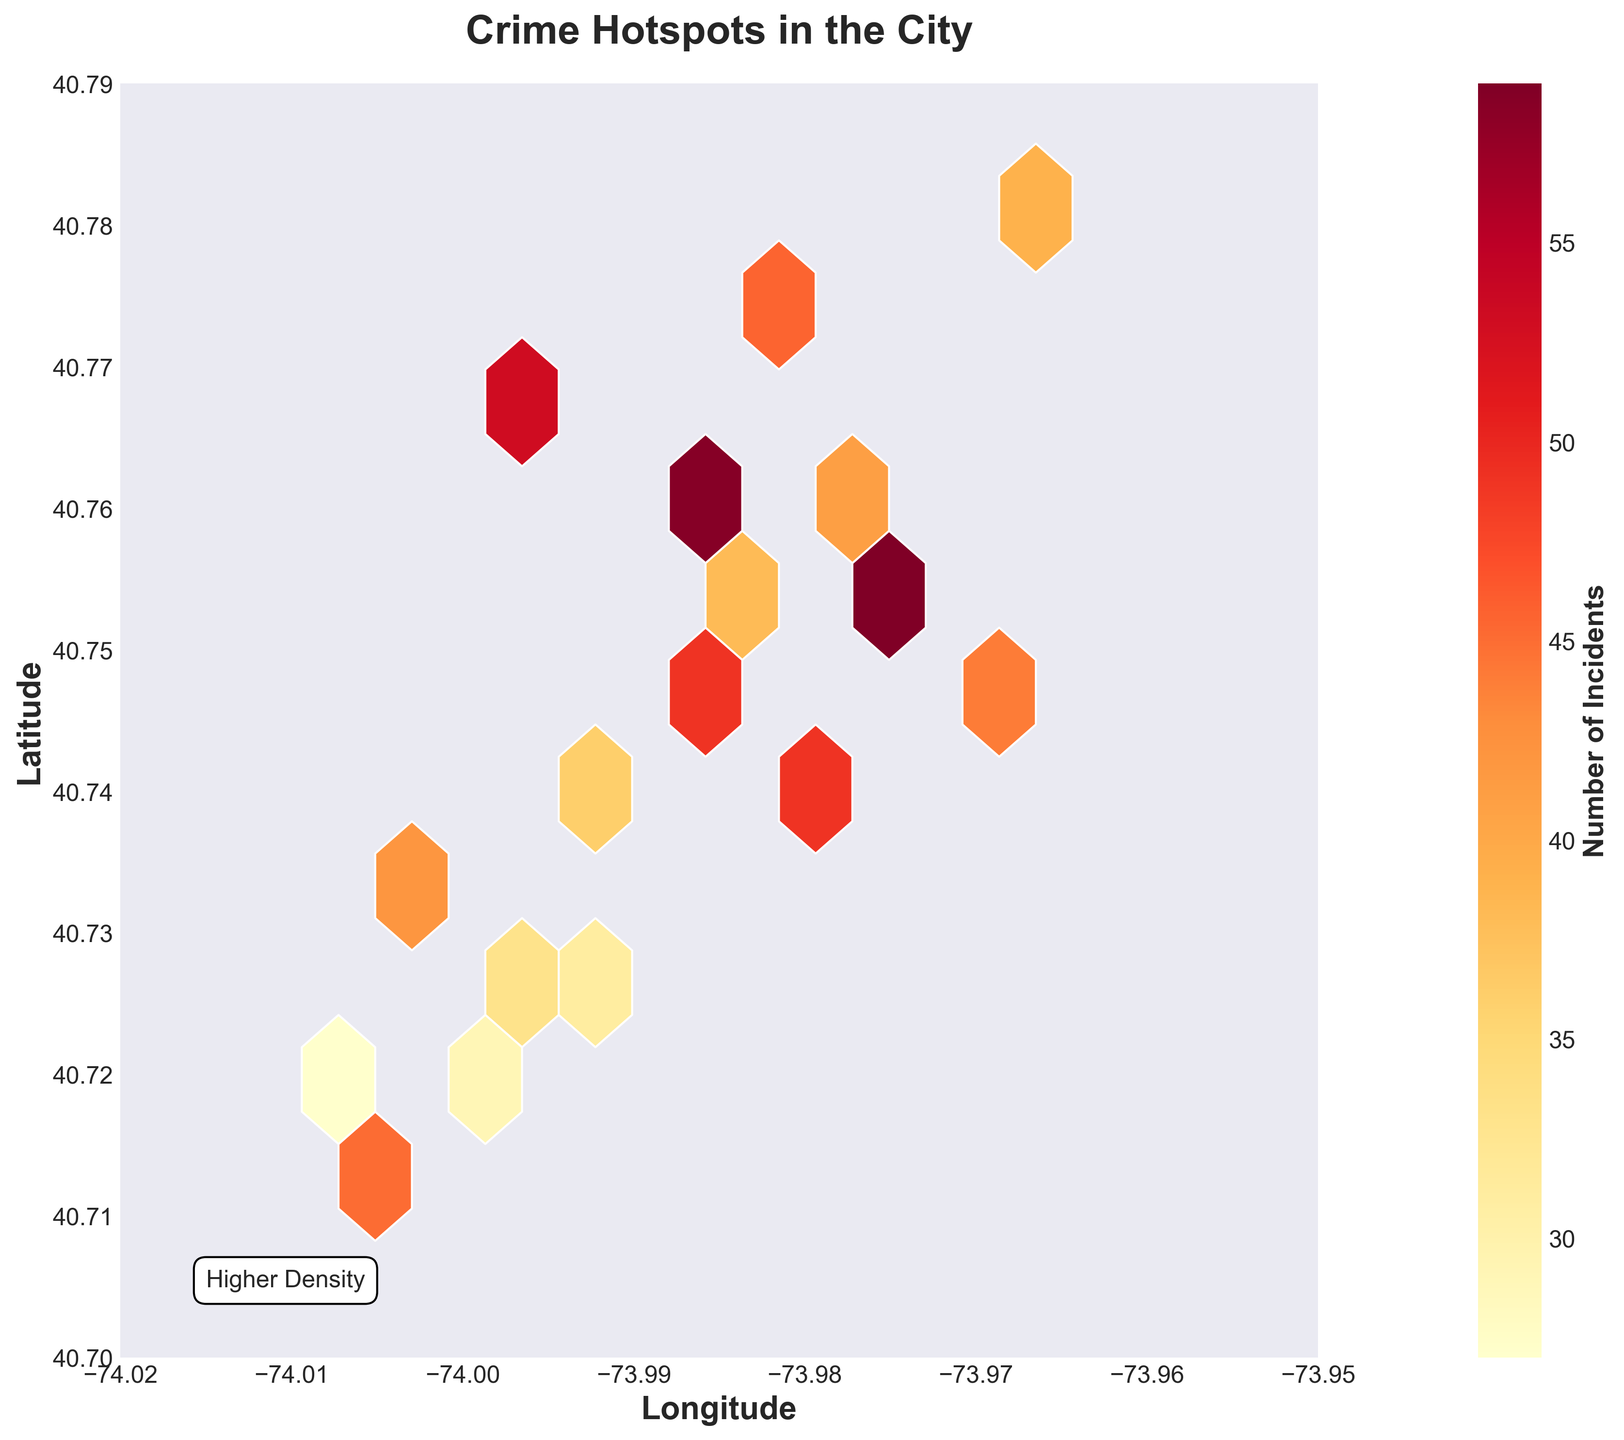What is the title of the plot? The title of the plot is usually displayed at the top of the figure. In this plot, it indicates the main focus of the visualization.
Answer: Crime Hotspots in the City What do the colors in the plot represent? The color gradient in the hexbin plot represents the number of crime incidents. Brighter colors indicate higher incident density, and darker colors indicate lower density.
Answer: Number of Incidents What are the axis labels in the hexbin plot? The axis labels give context to the data plotted along each axis. The horizontal axis (x-axis) is labeled "Longitude," and the vertical axis (y-axis) is labeled "Latitude."
Answer: Longitude and Latitude In which longitude and latitude range does the data lie? The axis limits show the range of data. The longitude ranges from -74.02 to -73.95, and the latitude ranges from 40.70 to 40.79.
Answer: -74.02 to -73.95 (Longitude) and 40.70 to 40.79 (Latitude) How is the density of incidents represented in the plot? Density is represented by the concentration of hexagons and their color intensity. More dense areas have more hexagons with brighter colors.
Answer: Concentration and color intensity of hexagons Which area seems to have the highest density of crime incidents? To identify the area with the highest density of incidents, look for the cluster of hexagons with the brightest color. This area is at higher latitudes and near the center.
Answer: Near 40.76 Latitude and -73.98 Longitude Is there a noticeable gradient in the number of incidents from one side of the plot to the other? By observing the color gradient from one side of the plot to the other, you can see if there is a pattern of increasing or decreasing density. The plot shows a gradient where incident density increases toward the center.
Answer: Yes, density increases toward the center What does the color bar indicate? The color bar is a legend explaining what the different colors in the hexagons represent, specifically the number of crime incidents. Higher values on the color bar correspond to more incidents.
Answer: Number of Incidents How many hotspots with a high number of incidents can you identify? Hotspots are areas with high incident density, identified by clusters of brightly colored hexagons. In this figure, there appear to be around 2-3 major hotspots.
Answer: 2-3 hotspots What is the range of the highest number of incidents depicted in the color bar? The maximum value on the color bar provides the range of the highest number of incidents. From the figure, the range on the color bar reaches up to around 60 incidents.
Answer: Up to 60 incidents 